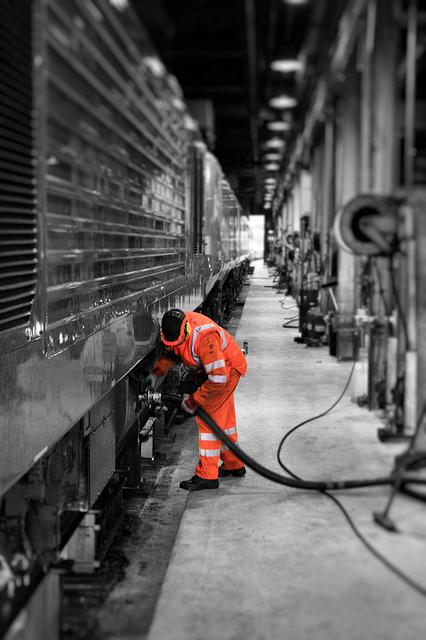What the person doing?
Short answer required. Working. Is this person wearing safety clothes?
Answer briefly. Yes. What color are the stripes on his outfit?
Write a very short answer. White. 